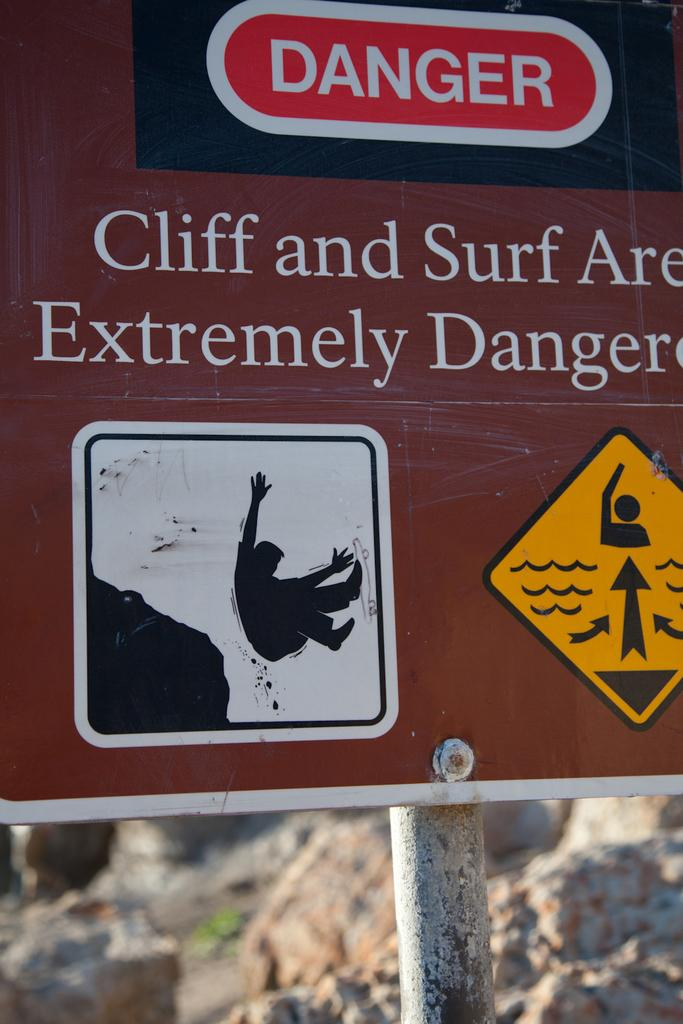What is the main object in the image? There is a brown-colored board in the image. How is the board positioned in the image? The board is attached to a pole. What can be seen on the board? There is writing on the board. What type of natural elements are visible in the background of the image? The background of the image includes rocks. What type of pan is being used to cook food in the image? There is no pan or cooking activity present in the image; it features a brown-colored board attached to a pole with writing on it. What type of punishment is being administered to the daughter in the image? There is no daughter or punishment present in the image; it features a brown-colored board attached to a pole with writing on it. 